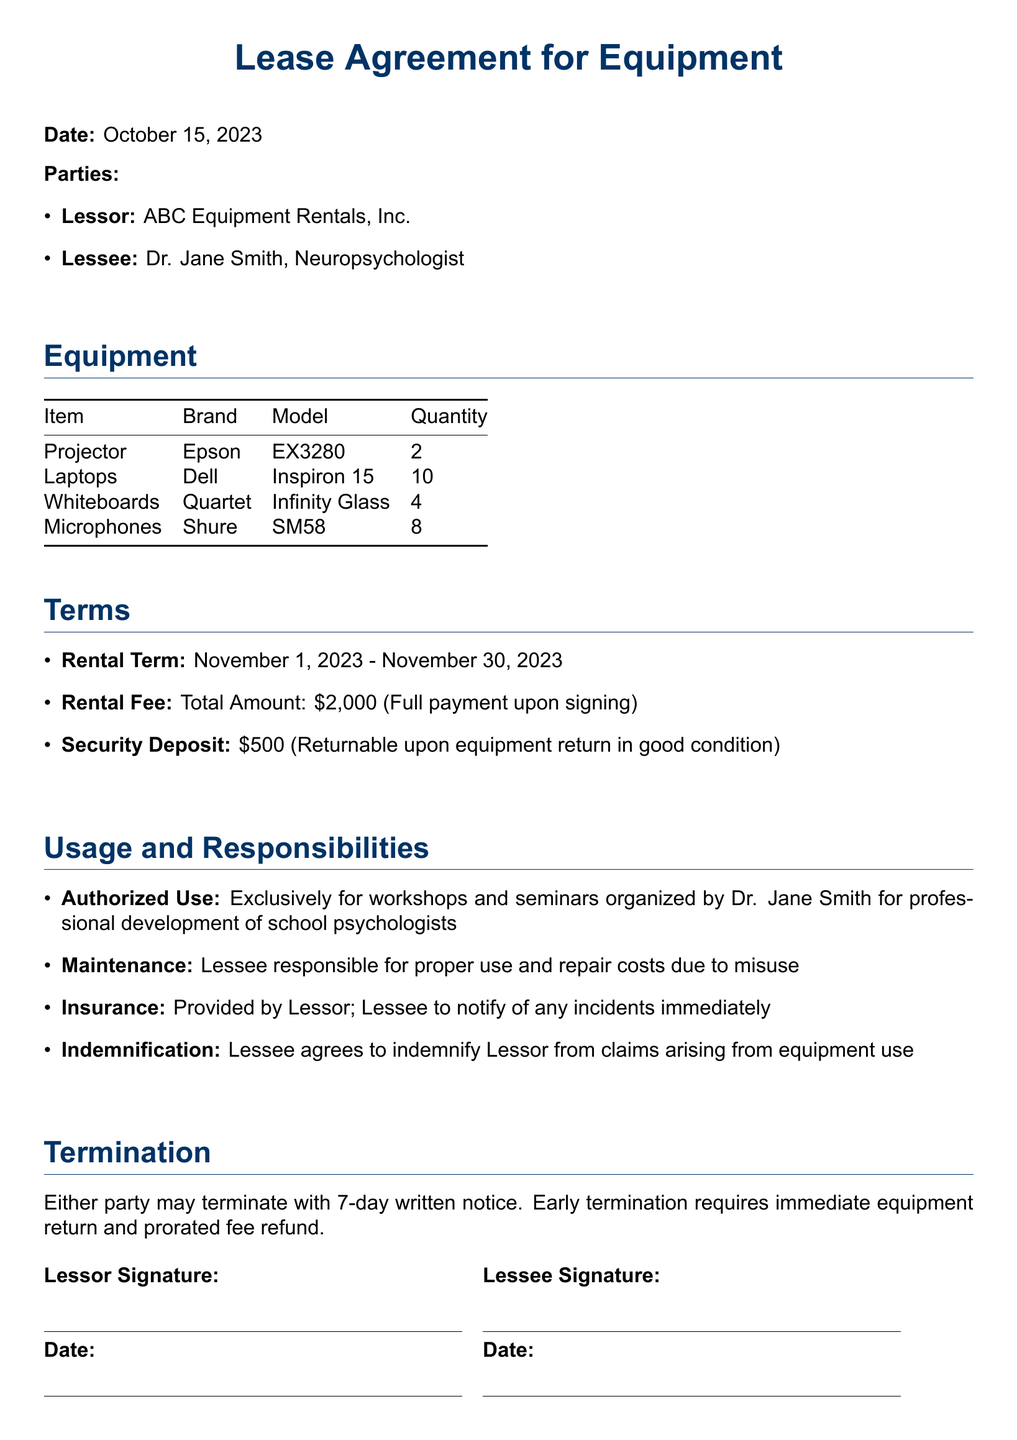What is the rental term? The rental term is specified in the terms section of the document.
Answer: November 1, 2023 - November 30, 2023 What is the total rental fee? The total rental fee is mentioned in the terms section, indicating the full amount due.
Answer: $2,000 Who is the lessee? The lessee’s name is stated in the parties section of the document.
Answer: Dr. Jane Smith, Neuropsychologist How many laptops are included in the lease? The quantity of laptops is provided in the equipment section of the document.
Answer: 10 What is the amount of the security deposit? The amount of the security deposit is outlined in the terms section of the document.
Answer: $500 What is the authorized use of the equipment? The authorized use is described in the usage and responsibilities section.
Answer: Exclusively for workshops and seminars organized by Dr. Jane Smith What is required for early termination? The requirements for early termination are specified under the termination section of the document.
Answer: Immediate equipment return and prorated fee refund Who provides the insurance for the equipment? The party responsible for insurance is specified in the usage and responsibilities section.
Answer: Provided by Lessor What should the lessee do in case of incidents? The procedure in case of incidents is outlined in the usage and responsibilities section.
Answer: Notify of any incidents immediately 